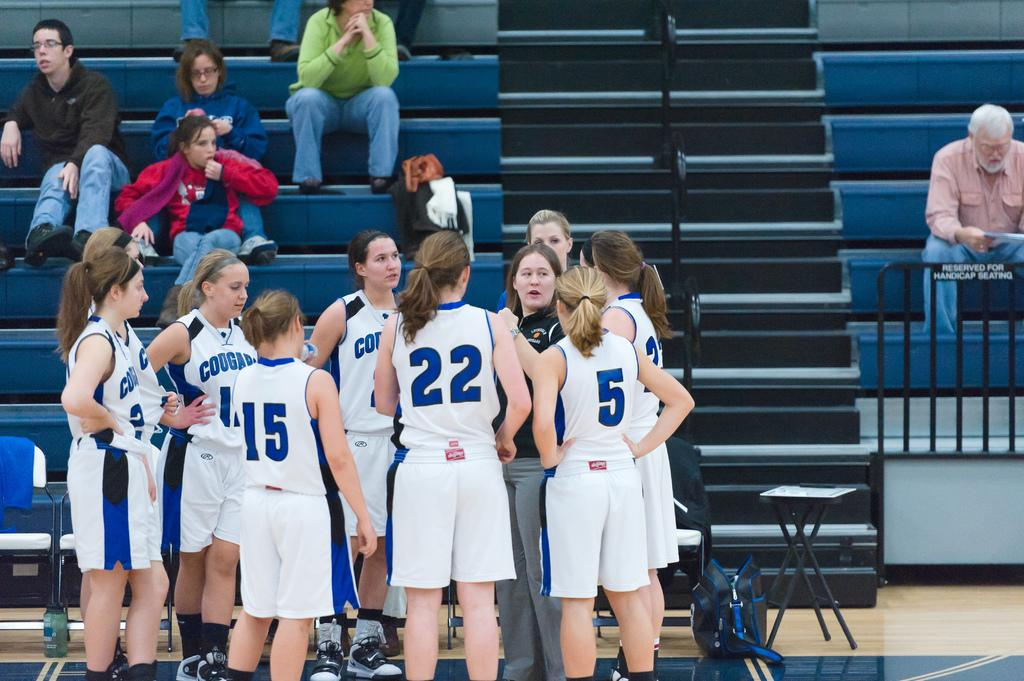<image>
Render a clear and concise summary of the photo. The Cougars female basketball team huddles in front of the bleachers. 